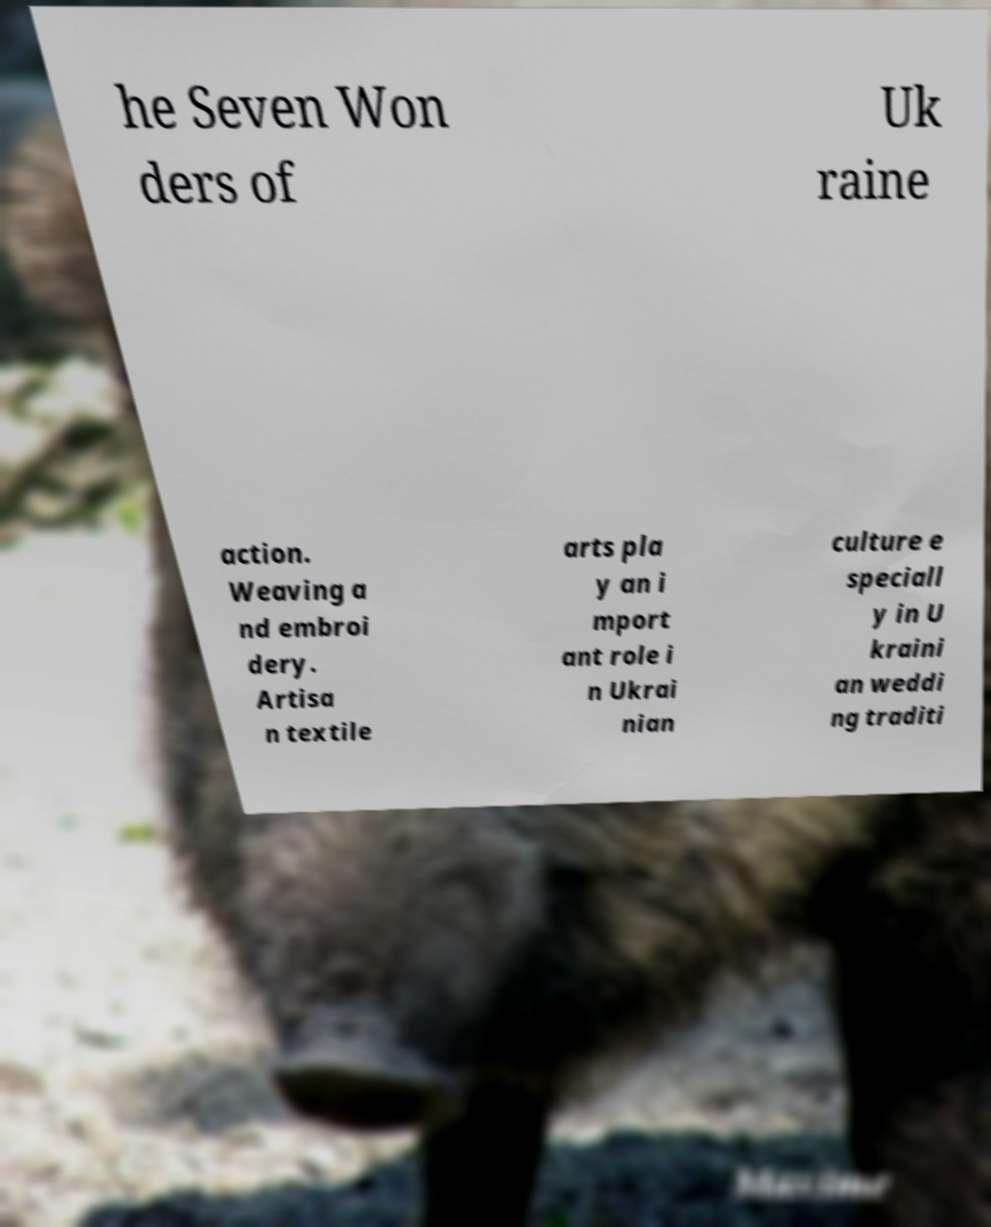Can you accurately transcribe the text from the provided image for me? he Seven Won ders of Uk raine action. Weaving a nd embroi dery. Artisa n textile arts pla y an i mport ant role i n Ukrai nian culture e speciall y in U kraini an weddi ng traditi 